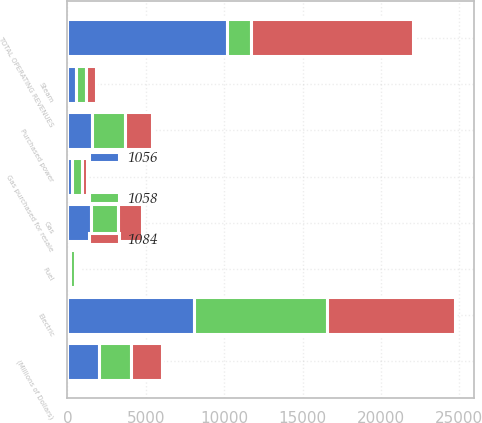Convert chart to OTSL. <chart><loc_0><loc_0><loc_500><loc_500><stacked_bar_chart><ecel><fcel>(Millions of Dollars)<fcel>Electric<fcel>Gas<fcel>Steam<fcel>TOTAL OPERATING REVENUES<fcel>Purchased power<fcel>Fuel<fcel>Gas purchased for resale<nl><fcel>1056<fcel>2016<fcel>8106<fcel>1508<fcel>551<fcel>10165<fcel>1568<fcel>172<fcel>319<nl><fcel>1084<fcel>2015<fcel>8172<fcel>1527<fcel>629<fcel>10328<fcel>1719<fcel>248<fcel>337<nl><fcel>1058<fcel>2014<fcel>8437<fcel>1721<fcel>628<fcel>1568<fcel>2091<fcel>285<fcel>609<nl></chart> 